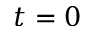Convert formula to latex. <formula><loc_0><loc_0><loc_500><loc_500>t = 0</formula> 